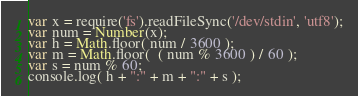<code> <loc_0><loc_0><loc_500><loc_500><_JavaScript_>var x = require('fs').readFileSync('/dev/stdin', 'utf8');
var num = Number(x);
var h = Math.floor( num / 3600 );
var m = Math.floor(  ( num % 3600 ) / 60 );
var s = num % 60;
console.log( h + ":" + m + ":" + s );</code> 